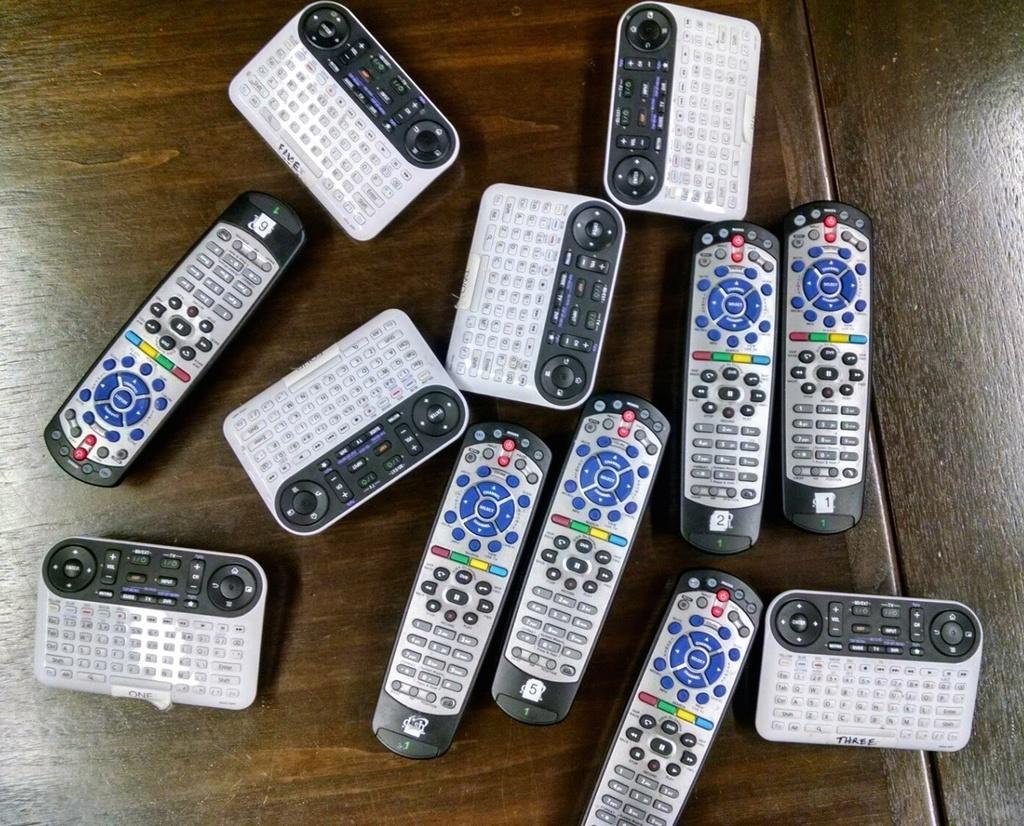<image>
Render a clear and concise summary of the photo. A pile of remotes with blue, green, red, and yellow buttons and labeled three. 